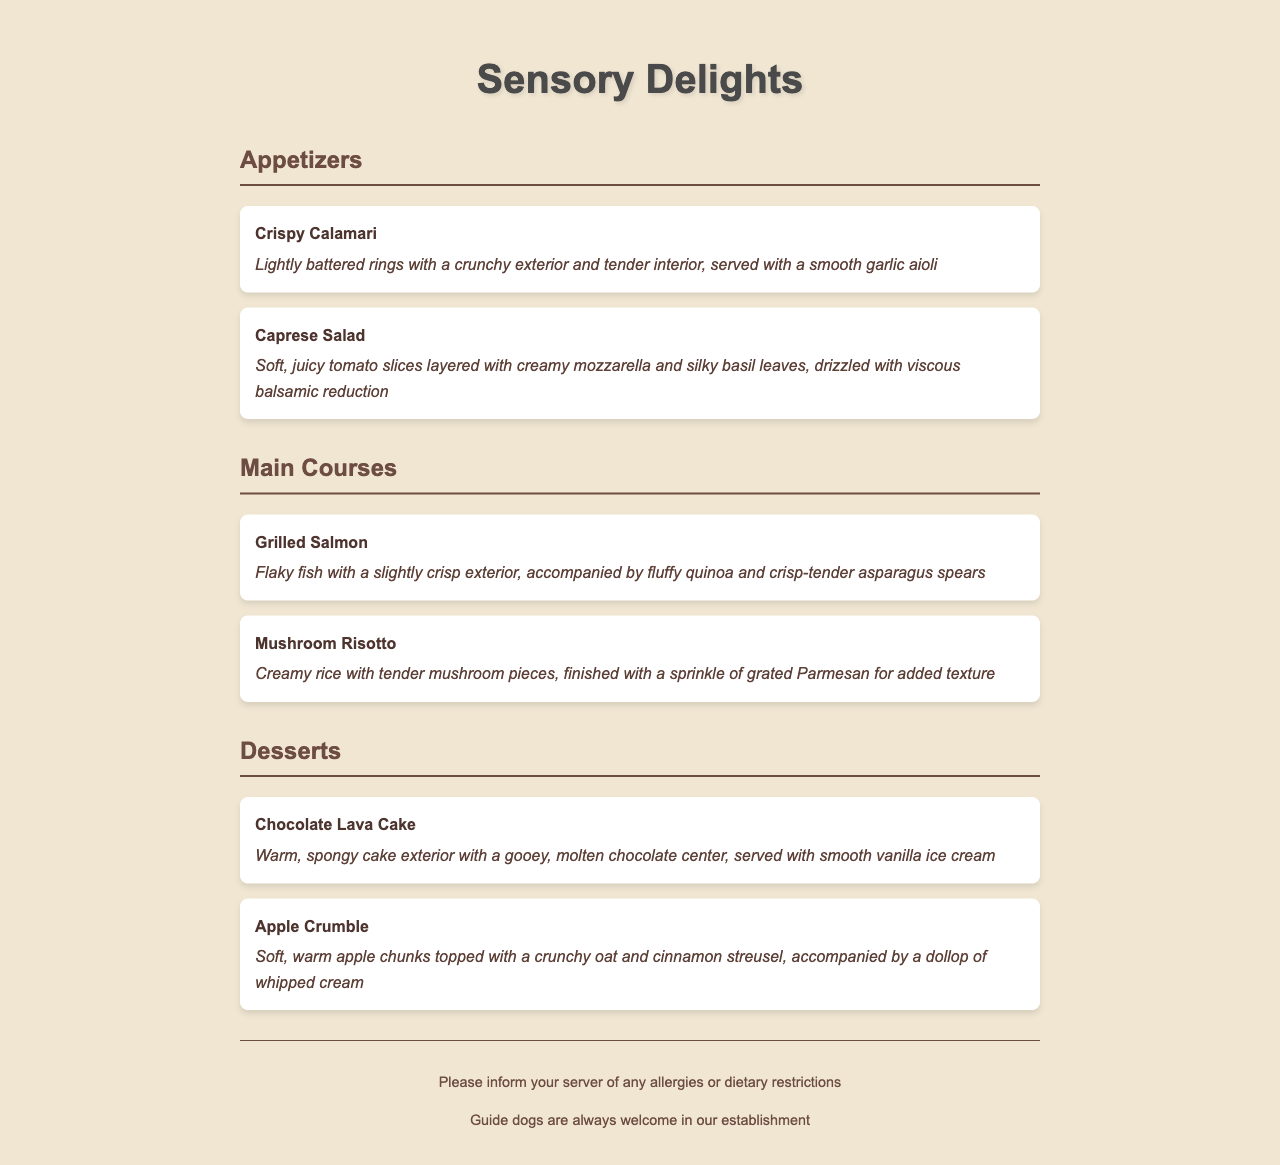what is the name of the first appetizer? The first appetizer listed in the document is "Crispy Calamari."
Answer: Crispy Calamari what texture is described for the Grilled Salmon? The texture description for the Grilled Salmon indicates that it is "Flaky fish with a slightly crisp exterior."
Answer: Flaky fish with a slightly crisp exterior how many main courses are listed in the menu? There are two main courses mentioned in the menu: Grilled Salmon and Mushroom Risotto.
Answer: 2 what is the topping for the Apple Crumble? The Apple Crumble is topped with a "crunchy oat and cinnamon streusel."
Answer: crunchy oat and cinnamon streusel which dessert has a molten chocolate center? The dessert that features a molten chocolate center is the "Chocolate Lava Cake."
Answer: Chocolate Lava Cake which ingredient is used in the Caprese Salad? The Caprese Salad includes "creamy mozzarella" as one of its ingredients.
Answer: creamy mozzarella what is served with the Chocolate Lava Cake? The Chocolate Lava Cake is served with "smooth vanilla ice cream."
Answer: smooth vanilla ice cream what type of dish is Mushroom Risotto? Mushroom Risotto is categorized as a "Main Course" in the menu.
Answer: Main Course 